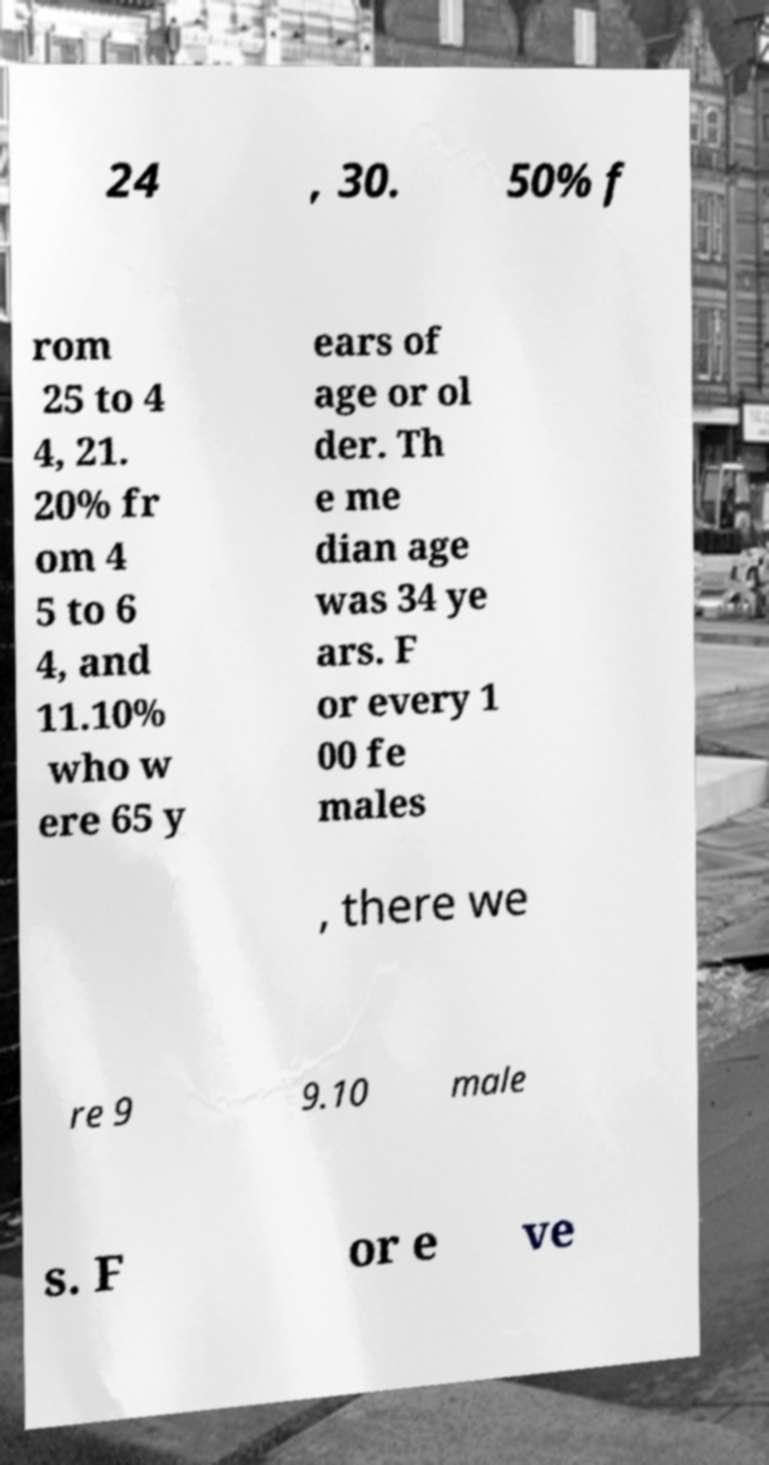Please read and relay the text visible in this image. What does it say? 24 , 30. 50% f rom 25 to 4 4, 21. 20% fr om 4 5 to 6 4, and 11.10% who w ere 65 y ears of age or ol der. Th e me dian age was 34 ye ars. F or every 1 00 fe males , there we re 9 9.10 male s. F or e ve 